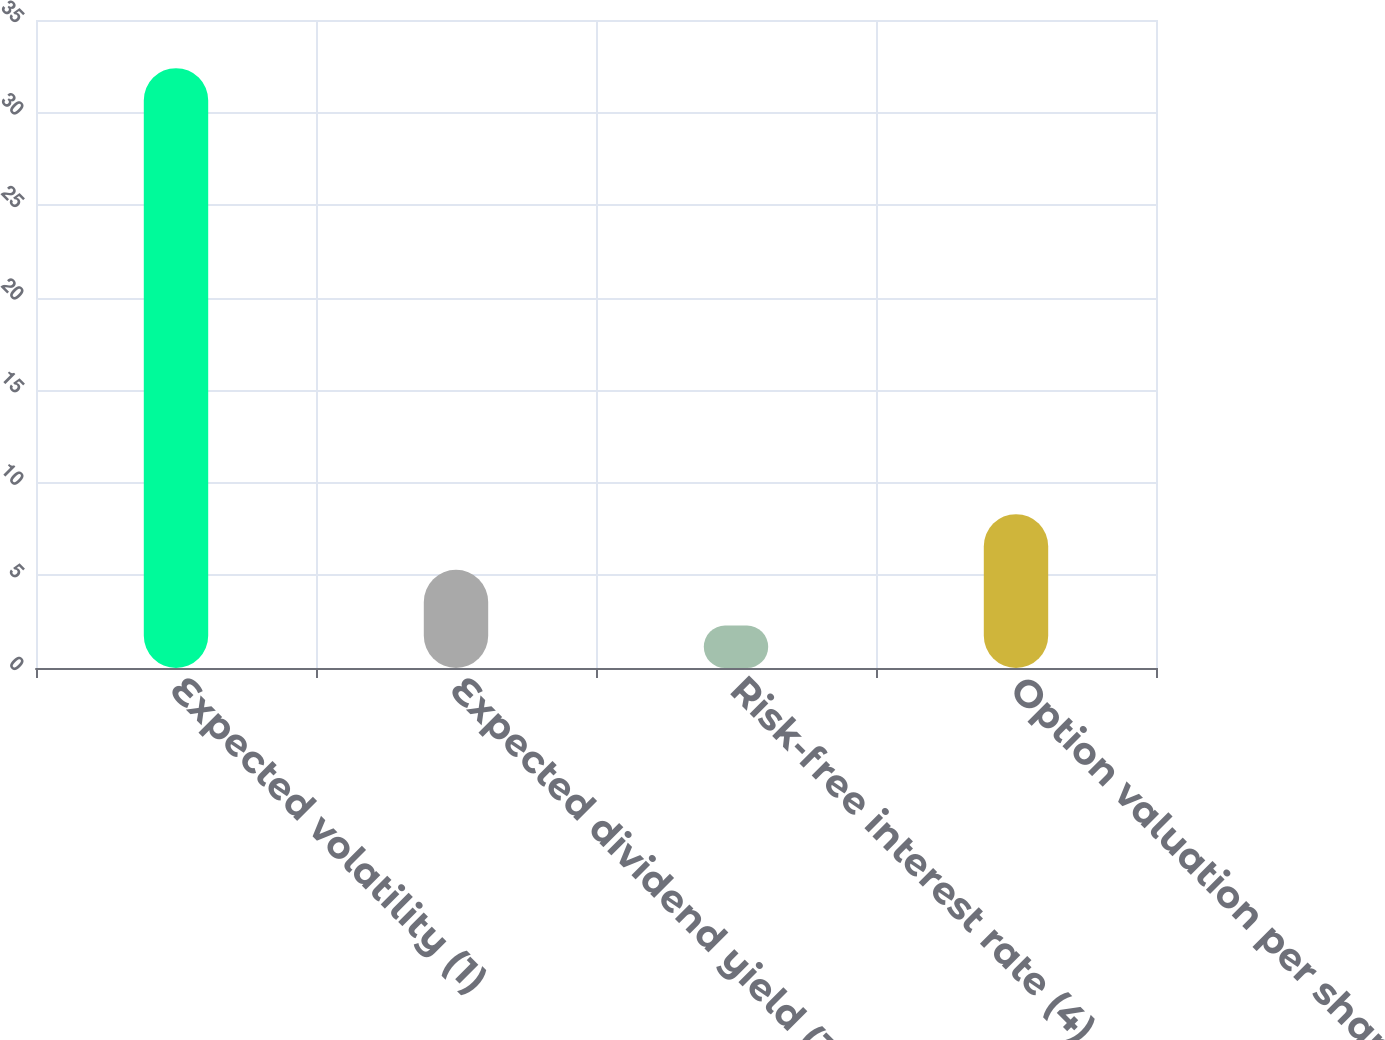Convert chart to OTSL. <chart><loc_0><loc_0><loc_500><loc_500><bar_chart><fcel>Expected volatility (1)<fcel>Expected dividend yield (3)<fcel>Risk-free interest rate (4)<fcel>Option valuation per share<nl><fcel>32.4<fcel>5.3<fcel>2.29<fcel>8.31<nl></chart> 